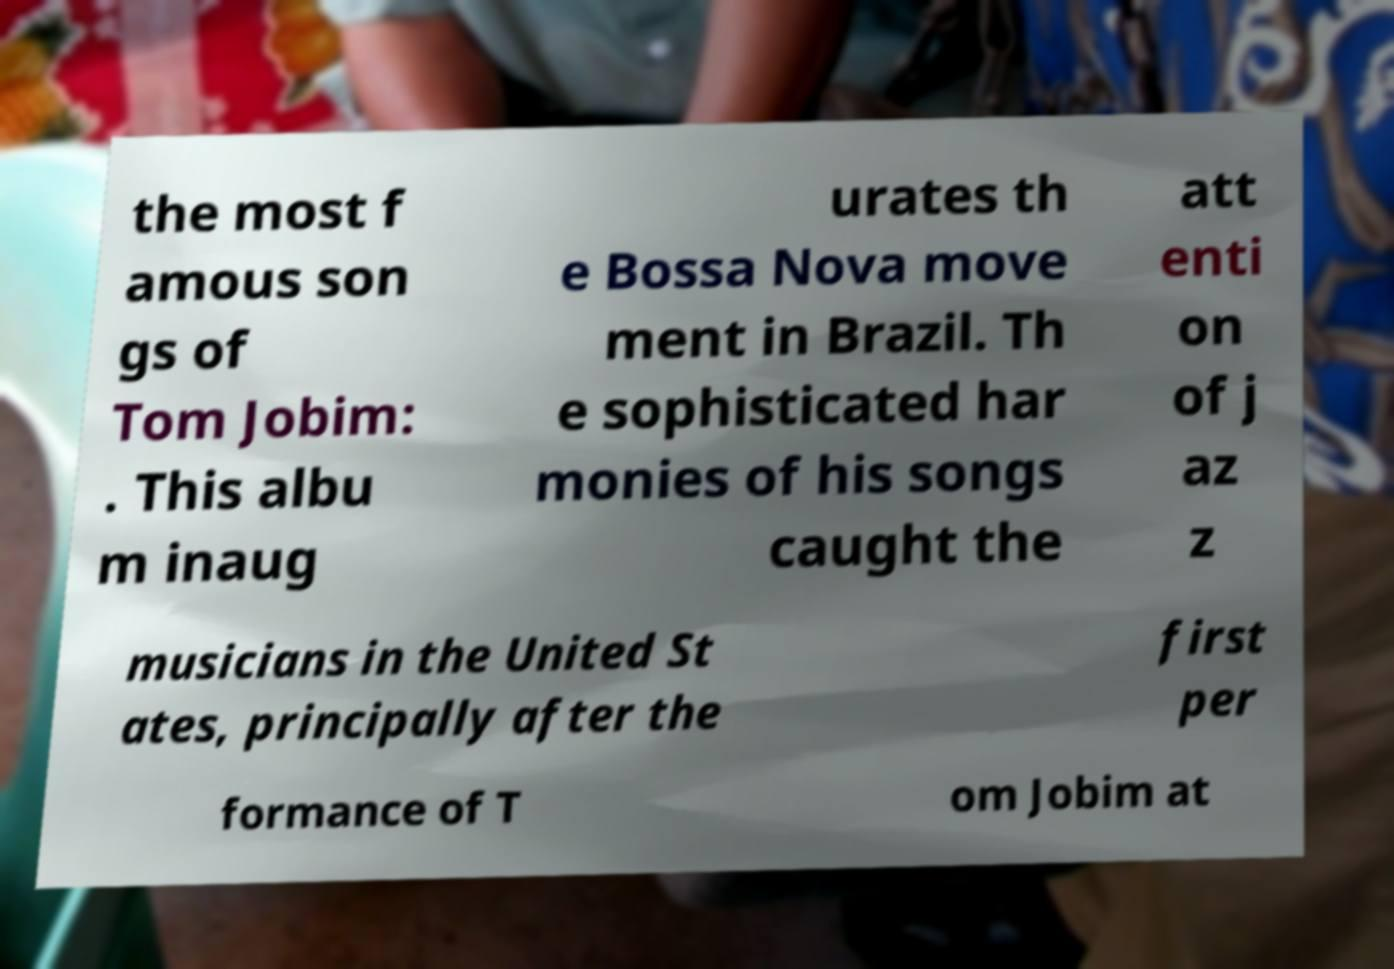Could you extract and type out the text from this image? the most f amous son gs of Tom Jobim: . This albu m inaug urates th e Bossa Nova move ment in Brazil. Th e sophisticated har monies of his songs caught the att enti on of j az z musicians in the United St ates, principally after the first per formance of T om Jobim at 